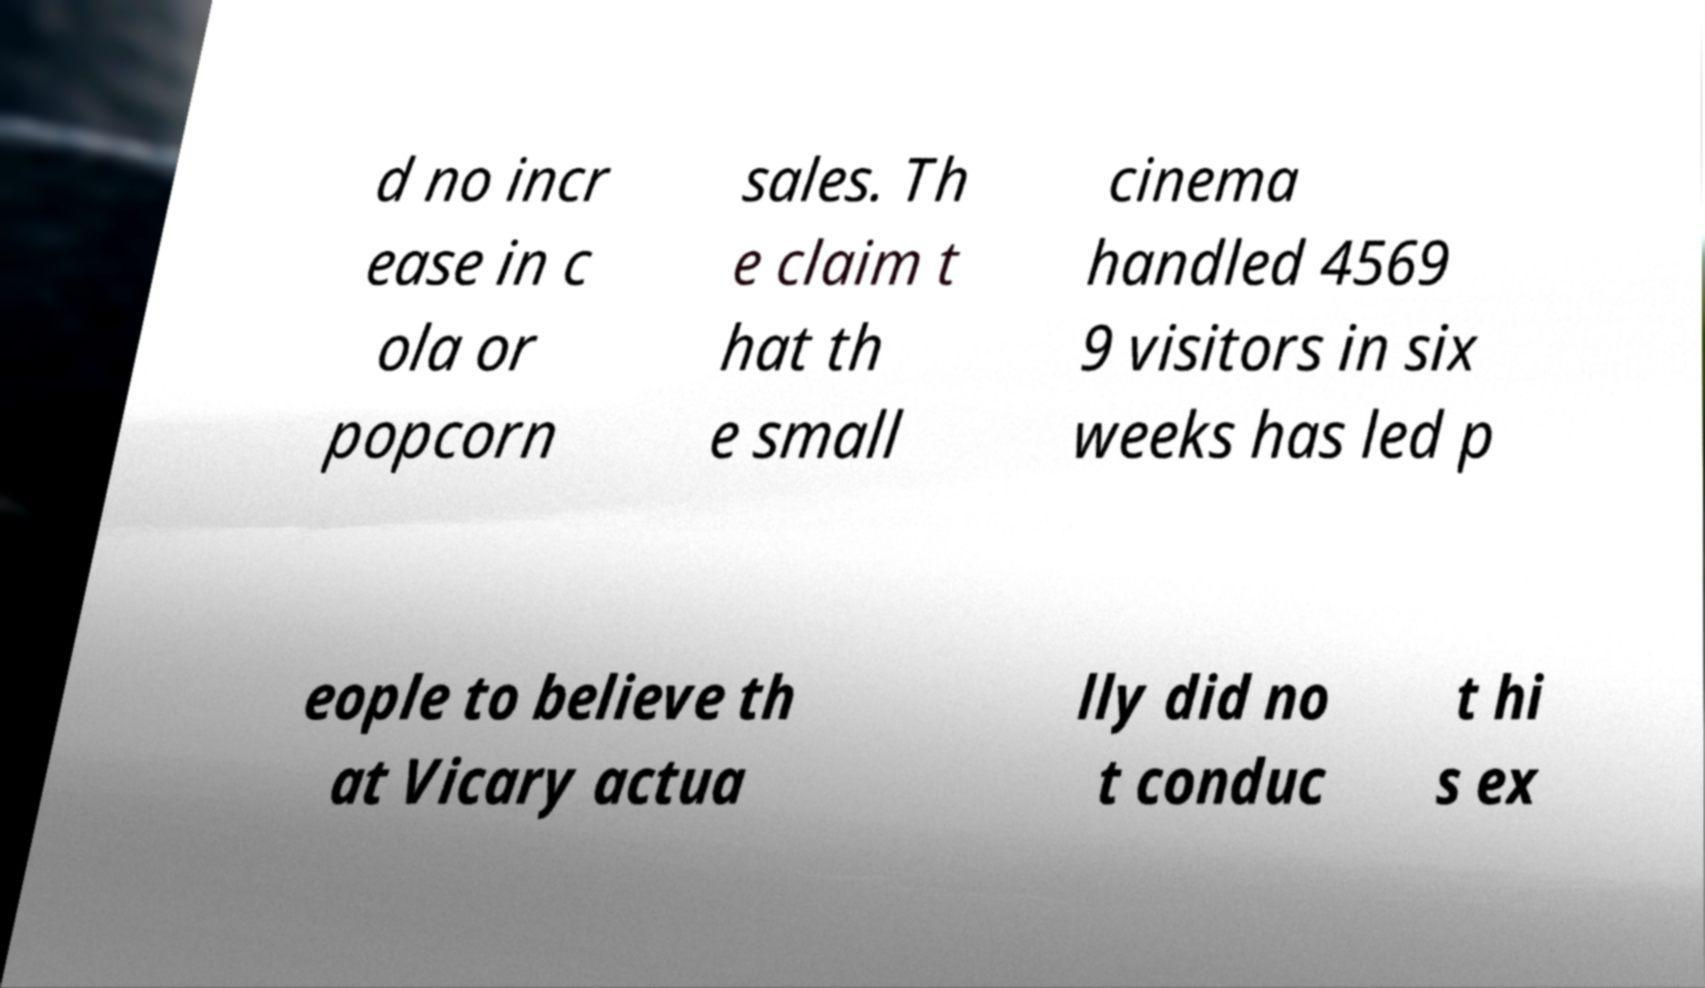Could you extract and type out the text from this image? d no incr ease in c ola or popcorn sales. Th e claim t hat th e small cinema handled 4569 9 visitors in six weeks has led p eople to believe th at Vicary actua lly did no t conduc t hi s ex 